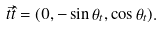Convert formula to latex. <formula><loc_0><loc_0><loc_500><loc_500>\vec { t } { \hat { t } } = ( 0 , - \sin \theta _ { t } , \cos \theta _ { t } ) .</formula> 